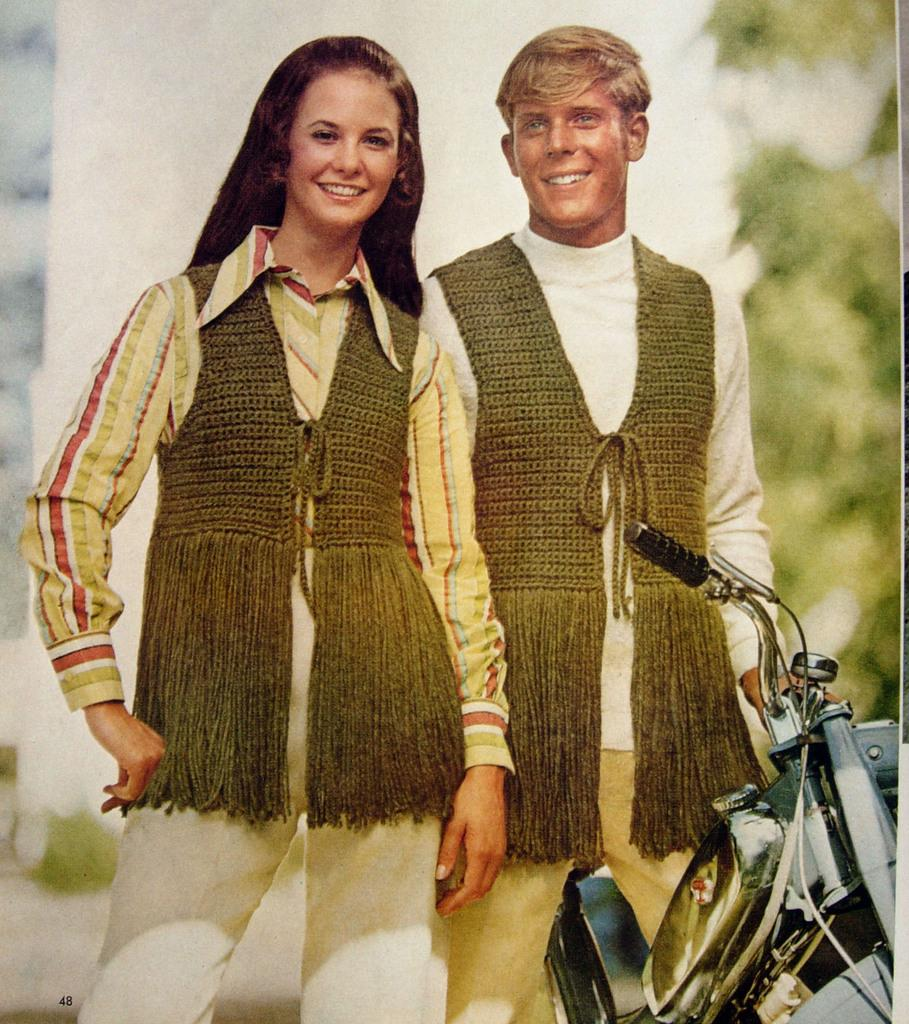How many people are in the image? There is a man and a woman in the image, making a total of two people. What are the man and the woman wearing? Both the man and the woman are wearing the same coats. What can be seen at the bottom of the image? There is a bike at the bottom of the image. What is on the right side of the image? There is a tree on the right side of the image. What type of linen is draped over the hill in the image? There is no hill or linen present in the image. What are the man and the woman eating for dinner in the image? There is no dinner or indication of food in the image. 